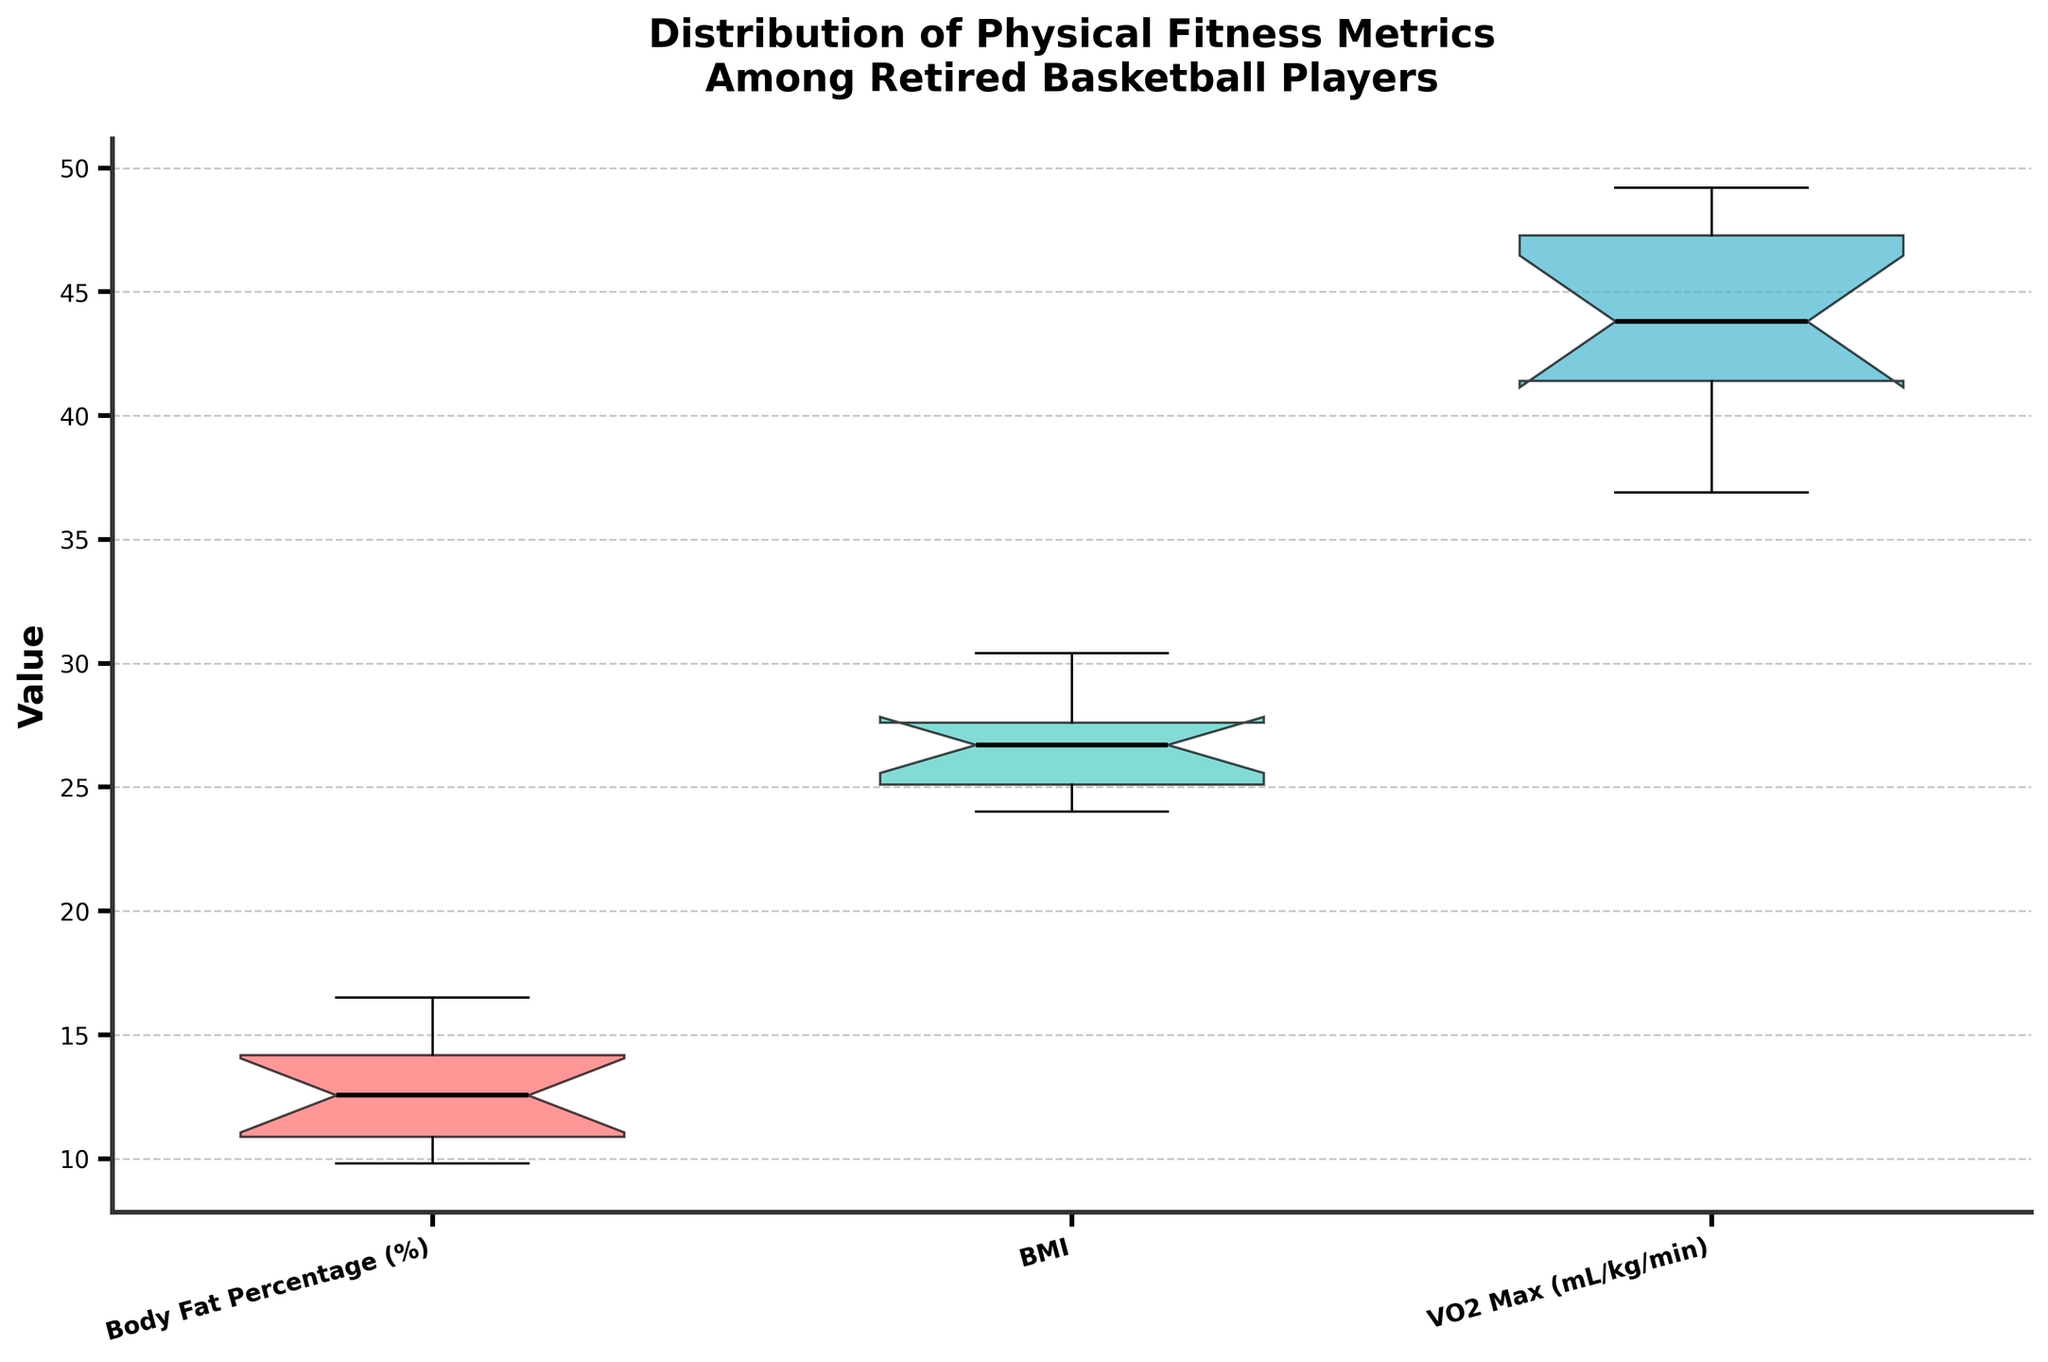What is the title of the chart? The title is displayed at the top center of the chart in bold font. It reads "Distribution of Physical Fitness Metrics Among Retired Basketball Players".
Answer: Distribution of Physical Fitness Metrics Among Retired Basketball Players What is the range of the Body Fat Percentage (%) for the players? The box plot shows the range of values for Body Fat Percentage (%) from the minimum (bottom whisker) to the maximum (top whisker).
Answer: Approximately 9.8% to 16.5% Which metric has the narrowest interquartile range (IQR)? The IQR is the range between the first quartile (Q1) and the third quartile (Q3). In the plot, the VO2 Max has the narrowest box, indicating the smallest IQR.
Answer: VO2 Max (mL/kg/min) How many metrics are compared in the box plot? The x-axis shows three different categories of metrics being compared: Body Fat Percentage (%), BMI, and VO2 Max (mL/kg/min).
Answer: Three Which metric shows the greatest variability in the data? The variability can be observed from the length of the whiskers and the spread of the data within the box plot. BMI has the longest whiskers, indicating the greatest variability.
Answer: BMI What is the median BMI of the players? The median is represented by the line inside the box of the box plot. For BMI, the median line is near 26.6.
Answer: Approximately 26.6 Does the Body Fat Percentage (%) show any outliers? Outliers are usually represented by dots outside the whiskers in the box plot. The Body Fat Percentage (%) does not display any such dots.
Answer: No Which metric has the highest median value? The median value is indicated by the central line in each box. BMI has the highest median among the three metrics.
Answer: BMI What can you say about the notches in the box plot for BMI? Notches represent a confidence interval around the median. If notches between boxes do not overlap, it suggests a significant difference between medians. BMI's notches do not overlap with Body Fat Percentage (%), implying a significant difference.
Answer: The notches indicate significant differences between BMI and Body Fat Percentage (%) Is VO2 Max generally higher or lower compared to Body Fat Percentage (%) and BMI? VO2 Max values are generally higher as its box plot lies higher on the y-axis compared to the other two metrics.
Answer: Higher 